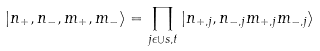<formula> <loc_0><loc_0><loc_500><loc_500>| n _ { + } , n _ { - } , m _ { + } , m _ { - } \rangle = \prod _ { j \epsilon \cup s , t } | n _ { + , j } , n _ { - , j } m _ { + , j } m _ { - , j } \rangle</formula> 